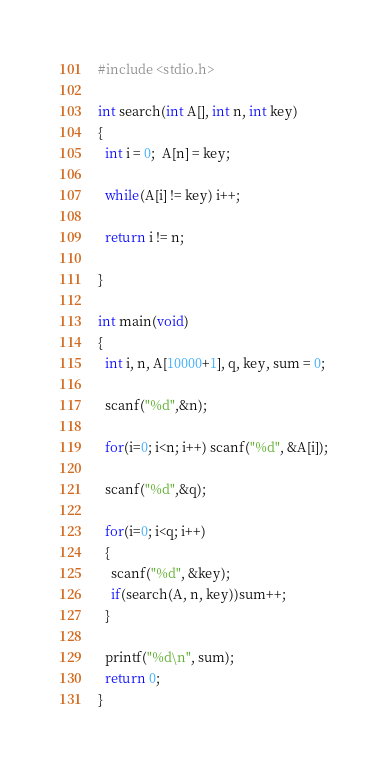Convert code to text. <code><loc_0><loc_0><loc_500><loc_500><_C_>#include <stdio.h>

int search(int A[], int n, int key) 
{
  int i = 0;  A[n] = key;
  
  while(A[i] != key) i++;

  return i != n;

}

int main(void) 
{
  int i, n, A[10000+1], q, key, sum = 0;

  scanf("%d",&n);

  for(i=0; i<n; i++) scanf("%d", &A[i]);

  scanf("%d",&q);

  for(i=0; i<q; i++)
  {
    scanf("%d", &key);
    if(search(A, n, key))sum++;
  }

  printf("%d\n", sum);
  return 0;
}
</code> 